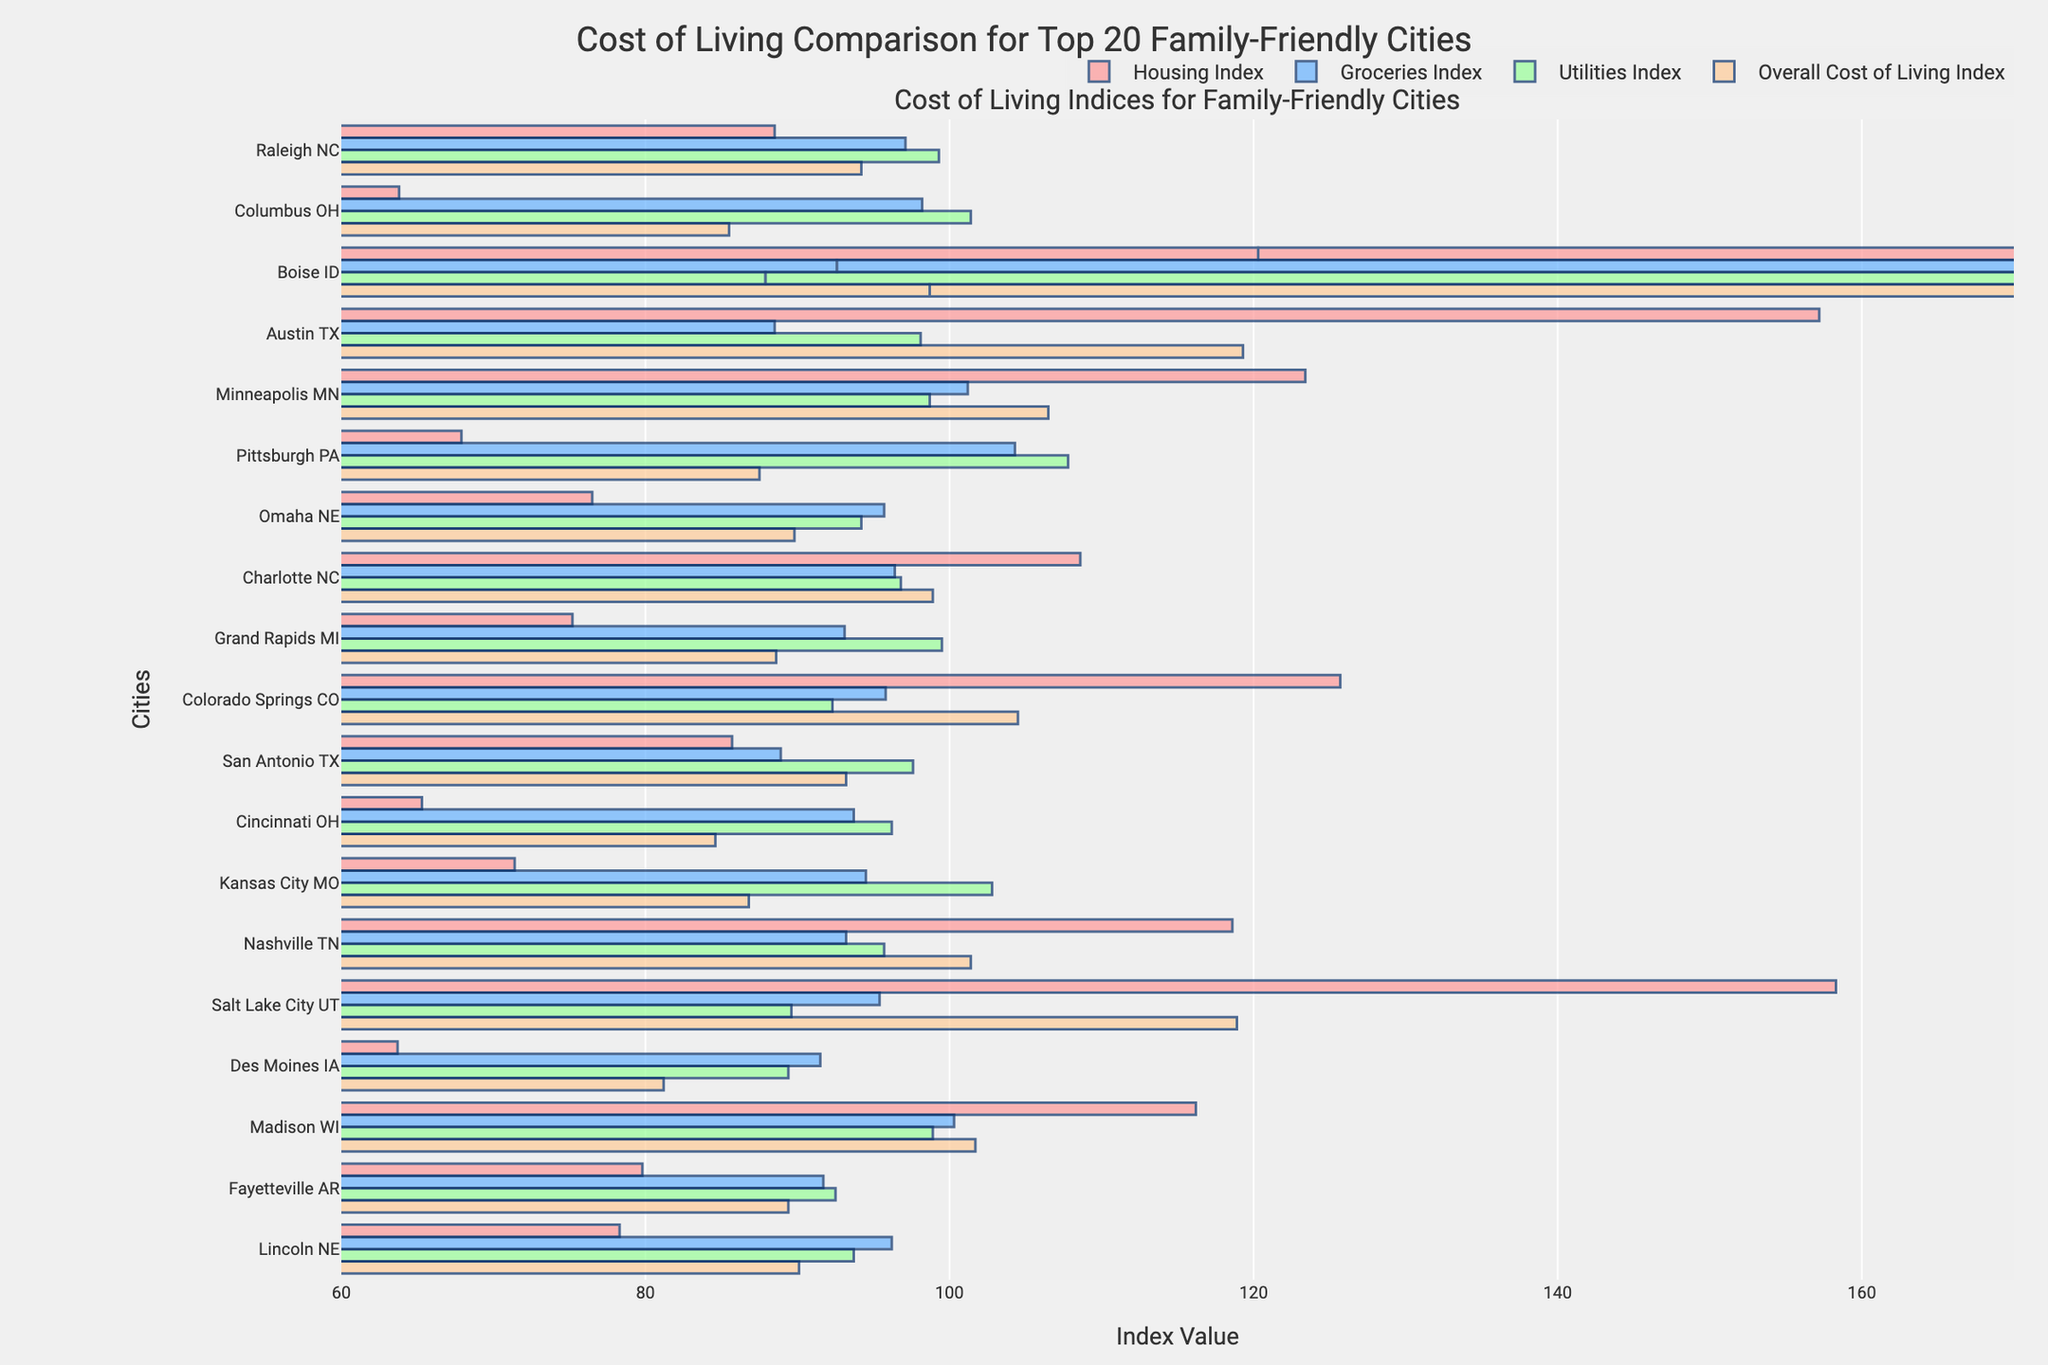Which city has the highest overall cost of living index? Look at the bar that represents the overall cost of living for each city. The bar with the longest length corresponds to Austin, TX.
Answer: Austin, TX Which city has the lowest housing index? Compare the lengths of the bars representing the housing index for all cities. The shortest bar corresponds to Columbus, OH.
Answer: Columbus, OH What is the average of the groceries index for Raleigh, NC and Nashville, TN? Identify the groceries index values for Raleigh, NC (97.1) and Nashville, TN (93.2). Add these values (97.1 + 93.2 = 190.3) and divide by 2 to find the average: 190.3/2 = 95.15.
Answer: 95.15 Which city has a higher utilities index, Kansas City, MO or Salt Lake City, UT? Compare the lengths of the bars representing the utilities index for these two cities. Kansas City, MO has a utilities index of 102.8, while Salt Lake City, UT has a utilities index of 89.6.
Answer: Kansas City, MO Are there any cities where the utilities index is higher than the groceries index? Compare the bars for the utilities index and groceries index for each city. Cities like Kansas City, MO (102.8 vs. 94.5) and Pittsburgh, PA (107.8 vs. 104.3) have a utilities index higher than the groceries index.
Answer: Yes Which city has almost equal values for the groceries index and the utilities index? Look for cities where the lengths of the bars for groceries index and utilities index are similar. For example, Colorado Springs, CO has groceries (95.8) and utilities (92.3) which are quite close.
Answer: Colorado Springs, CO What is the combined index value of housing and groceries for Boise, ID? Identify the housing and groceries index values for Boise, ID (120.3 and 92.6). Add these values together to get the combined index: 120.3 + 92.6 = 212.9.
Answer: 212.9 Are Raleigh, NC and San Antonio, TX closer in their overall cost of living or housing index? Compare the values for overall cost of living (Raleigh, NC: 94.2 and San Antonio, TX: 93.2) and housing index (Raleigh, NC: 88.5 and San Antonio, TX: 85.7). The overall cost of living indices are closer (94.2 - 93.2 = 1.0) compared to the housing indices (88.5 - 85.7 = 2.8).
Answer: Overall cost of living What is the sum of the utilities index for all cities starting with 'C'? Identify and sum the utilities index values for Columbus, OH (101.4), Charlotte, NC (96.8), and Cincinnati, OH (96.2). Sum: 101.4 + 96.8 + 96.2 = 294.4.
Answer: 294.4 Which index is the highest for Salt Lake City, UT? Compare the lengths of the bars for housing, groceries, utilities, and overall cost of living indices for Salt Lake City, UT. The housing index (158.3) is the highest among all.
Answer: Housing Index 